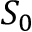Convert formula to latex. <formula><loc_0><loc_0><loc_500><loc_500>S _ { 0 }</formula> 